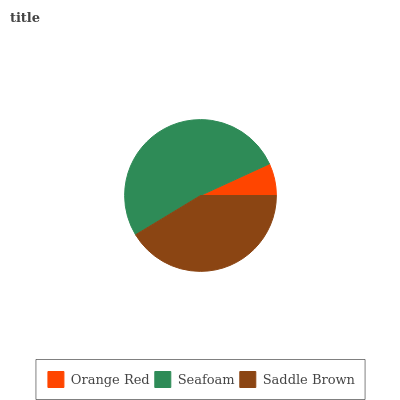Is Orange Red the minimum?
Answer yes or no. Yes. Is Seafoam the maximum?
Answer yes or no. Yes. Is Saddle Brown the minimum?
Answer yes or no. No. Is Saddle Brown the maximum?
Answer yes or no. No. Is Seafoam greater than Saddle Brown?
Answer yes or no. Yes. Is Saddle Brown less than Seafoam?
Answer yes or no. Yes. Is Saddle Brown greater than Seafoam?
Answer yes or no. No. Is Seafoam less than Saddle Brown?
Answer yes or no. No. Is Saddle Brown the high median?
Answer yes or no. Yes. Is Saddle Brown the low median?
Answer yes or no. Yes. Is Seafoam the high median?
Answer yes or no. No. Is Orange Red the low median?
Answer yes or no. No. 